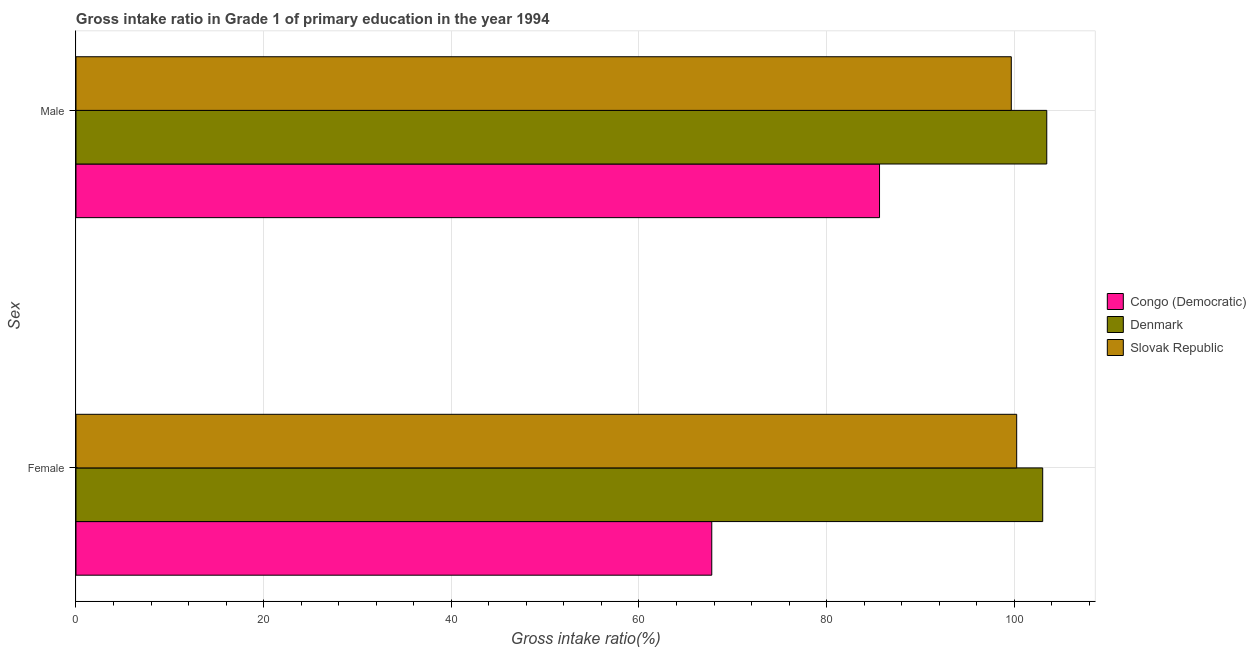How many groups of bars are there?
Keep it short and to the point. 2. Are the number of bars per tick equal to the number of legend labels?
Offer a terse response. Yes. How many bars are there on the 2nd tick from the top?
Offer a terse response. 3. What is the gross intake ratio(female) in Denmark?
Make the answer very short. 103.03. Across all countries, what is the maximum gross intake ratio(male)?
Your answer should be very brief. 103.47. Across all countries, what is the minimum gross intake ratio(female)?
Your response must be concise. 67.76. In which country was the gross intake ratio(male) maximum?
Offer a terse response. Denmark. In which country was the gross intake ratio(female) minimum?
Offer a terse response. Congo (Democratic). What is the total gross intake ratio(female) in the graph?
Ensure brevity in your answer.  271.05. What is the difference between the gross intake ratio(female) in Congo (Democratic) and that in Denmark?
Provide a short and direct response. -35.27. What is the difference between the gross intake ratio(female) in Slovak Republic and the gross intake ratio(male) in Congo (Democratic)?
Your answer should be compact. 14.62. What is the average gross intake ratio(female) per country?
Your answer should be very brief. 90.35. What is the difference between the gross intake ratio(male) and gross intake ratio(female) in Congo (Democratic)?
Provide a succinct answer. 17.88. What is the ratio of the gross intake ratio(female) in Slovak Republic to that in Denmark?
Provide a succinct answer. 0.97. What does the 2nd bar from the top in Male represents?
Your response must be concise. Denmark. What does the 3rd bar from the bottom in Female represents?
Keep it short and to the point. Slovak Republic. How many bars are there?
Your answer should be very brief. 6. What is the difference between two consecutive major ticks on the X-axis?
Offer a very short reply. 20. Are the values on the major ticks of X-axis written in scientific E-notation?
Ensure brevity in your answer.  No. Does the graph contain grids?
Offer a very short reply. Yes. What is the title of the graph?
Ensure brevity in your answer.  Gross intake ratio in Grade 1 of primary education in the year 1994. Does "Barbados" appear as one of the legend labels in the graph?
Offer a very short reply. No. What is the label or title of the X-axis?
Provide a succinct answer. Gross intake ratio(%). What is the label or title of the Y-axis?
Your answer should be compact. Sex. What is the Gross intake ratio(%) of Congo (Democratic) in Female?
Make the answer very short. 67.76. What is the Gross intake ratio(%) in Denmark in Female?
Make the answer very short. 103.03. What is the Gross intake ratio(%) of Slovak Republic in Female?
Give a very brief answer. 100.26. What is the Gross intake ratio(%) in Congo (Democratic) in Male?
Provide a short and direct response. 85.64. What is the Gross intake ratio(%) in Denmark in Male?
Offer a very short reply. 103.47. What is the Gross intake ratio(%) in Slovak Republic in Male?
Offer a terse response. 99.69. Across all Sex, what is the maximum Gross intake ratio(%) of Congo (Democratic)?
Offer a very short reply. 85.64. Across all Sex, what is the maximum Gross intake ratio(%) of Denmark?
Offer a terse response. 103.47. Across all Sex, what is the maximum Gross intake ratio(%) of Slovak Republic?
Provide a short and direct response. 100.26. Across all Sex, what is the minimum Gross intake ratio(%) of Congo (Democratic)?
Keep it short and to the point. 67.76. Across all Sex, what is the minimum Gross intake ratio(%) in Denmark?
Your answer should be compact. 103.03. Across all Sex, what is the minimum Gross intake ratio(%) in Slovak Republic?
Your answer should be compact. 99.69. What is the total Gross intake ratio(%) of Congo (Democratic) in the graph?
Keep it short and to the point. 153.4. What is the total Gross intake ratio(%) in Denmark in the graph?
Your response must be concise. 206.5. What is the total Gross intake ratio(%) of Slovak Republic in the graph?
Offer a terse response. 199.95. What is the difference between the Gross intake ratio(%) in Congo (Democratic) in Female and that in Male?
Provide a succinct answer. -17.88. What is the difference between the Gross intake ratio(%) in Denmark in Female and that in Male?
Keep it short and to the point. -0.43. What is the difference between the Gross intake ratio(%) of Slovak Republic in Female and that in Male?
Provide a short and direct response. 0.57. What is the difference between the Gross intake ratio(%) in Congo (Democratic) in Female and the Gross intake ratio(%) in Denmark in Male?
Provide a succinct answer. -35.7. What is the difference between the Gross intake ratio(%) of Congo (Democratic) in Female and the Gross intake ratio(%) of Slovak Republic in Male?
Provide a succinct answer. -31.92. What is the difference between the Gross intake ratio(%) of Denmark in Female and the Gross intake ratio(%) of Slovak Republic in Male?
Make the answer very short. 3.35. What is the average Gross intake ratio(%) of Congo (Democratic) per Sex?
Make the answer very short. 76.7. What is the average Gross intake ratio(%) in Denmark per Sex?
Provide a short and direct response. 103.25. What is the average Gross intake ratio(%) of Slovak Republic per Sex?
Your answer should be very brief. 99.97. What is the difference between the Gross intake ratio(%) of Congo (Democratic) and Gross intake ratio(%) of Denmark in Female?
Provide a succinct answer. -35.27. What is the difference between the Gross intake ratio(%) in Congo (Democratic) and Gross intake ratio(%) in Slovak Republic in Female?
Give a very brief answer. -32.5. What is the difference between the Gross intake ratio(%) of Denmark and Gross intake ratio(%) of Slovak Republic in Female?
Keep it short and to the point. 2.77. What is the difference between the Gross intake ratio(%) of Congo (Democratic) and Gross intake ratio(%) of Denmark in Male?
Ensure brevity in your answer.  -17.82. What is the difference between the Gross intake ratio(%) of Congo (Democratic) and Gross intake ratio(%) of Slovak Republic in Male?
Your response must be concise. -14.04. What is the difference between the Gross intake ratio(%) in Denmark and Gross intake ratio(%) in Slovak Republic in Male?
Offer a terse response. 3.78. What is the ratio of the Gross intake ratio(%) of Congo (Democratic) in Female to that in Male?
Your answer should be compact. 0.79. What is the ratio of the Gross intake ratio(%) of Denmark in Female to that in Male?
Provide a succinct answer. 1. What is the ratio of the Gross intake ratio(%) in Slovak Republic in Female to that in Male?
Provide a succinct answer. 1.01. What is the difference between the highest and the second highest Gross intake ratio(%) in Congo (Democratic)?
Provide a short and direct response. 17.88. What is the difference between the highest and the second highest Gross intake ratio(%) of Denmark?
Your answer should be very brief. 0.43. What is the difference between the highest and the second highest Gross intake ratio(%) of Slovak Republic?
Provide a succinct answer. 0.57. What is the difference between the highest and the lowest Gross intake ratio(%) in Congo (Democratic)?
Make the answer very short. 17.88. What is the difference between the highest and the lowest Gross intake ratio(%) in Denmark?
Ensure brevity in your answer.  0.43. What is the difference between the highest and the lowest Gross intake ratio(%) of Slovak Republic?
Provide a short and direct response. 0.57. 